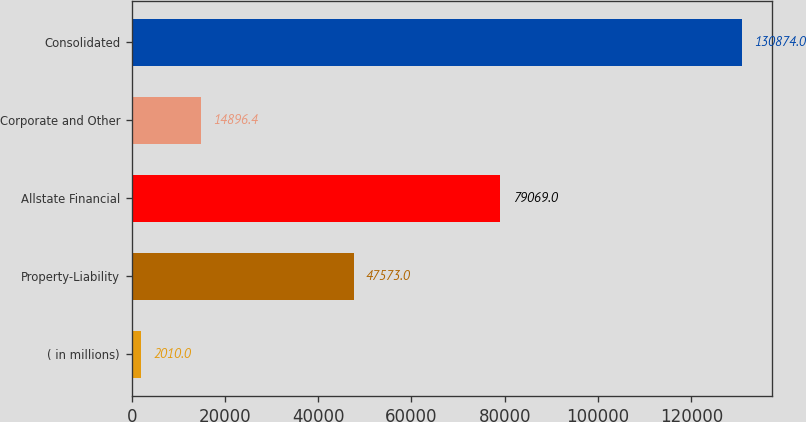Convert chart. <chart><loc_0><loc_0><loc_500><loc_500><bar_chart><fcel>( in millions)<fcel>Property-Liability<fcel>Allstate Financial<fcel>Corporate and Other<fcel>Consolidated<nl><fcel>2010<fcel>47573<fcel>79069<fcel>14896.4<fcel>130874<nl></chart> 